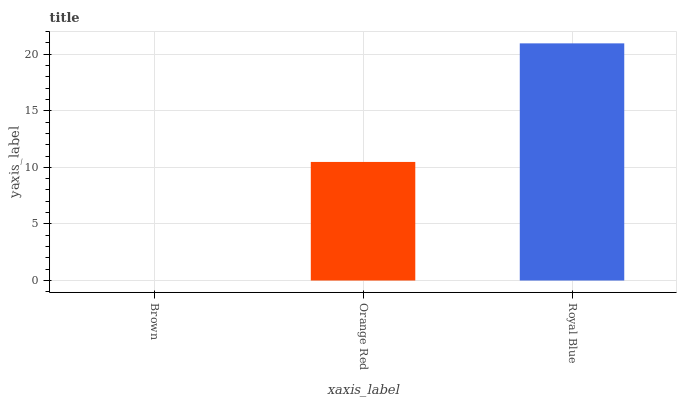Is Orange Red the minimum?
Answer yes or no. No. Is Orange Red the maximum?
Answer yes or no. No. Is Orange Red greater than Brown?
Answer yes or no. Yes. Is Brown less than Orange Red?
Answer yes or no. Yes. Is Brown greater than Orange Red?
Answer yes or no. No. Is Orange Red less than Brown?
Answer yes or no. No. Is Orange Red the high median?
Answer yes or no. Yes. Is Orange Red the low median?
Answer yes or no. Yes. Is Royal Blue the high median?
Answer yes or no. No. Is Royal Blue the low median?
Answer yes or no. No. 